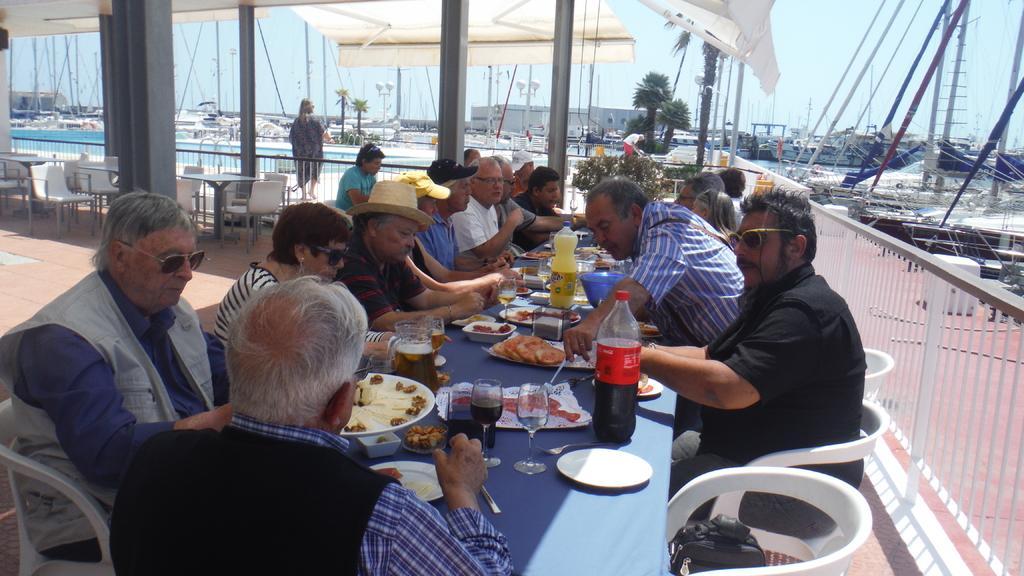Please provide a concise description of this image. In this picture there are many people sitting. In middle there is a table. There are many food items. There is a plate, jug,glass, soft-drink bottles. There is a bag on the chair. At the back there are two trees. In the top there is a tent. We can see water. There are many tables and chairs. 